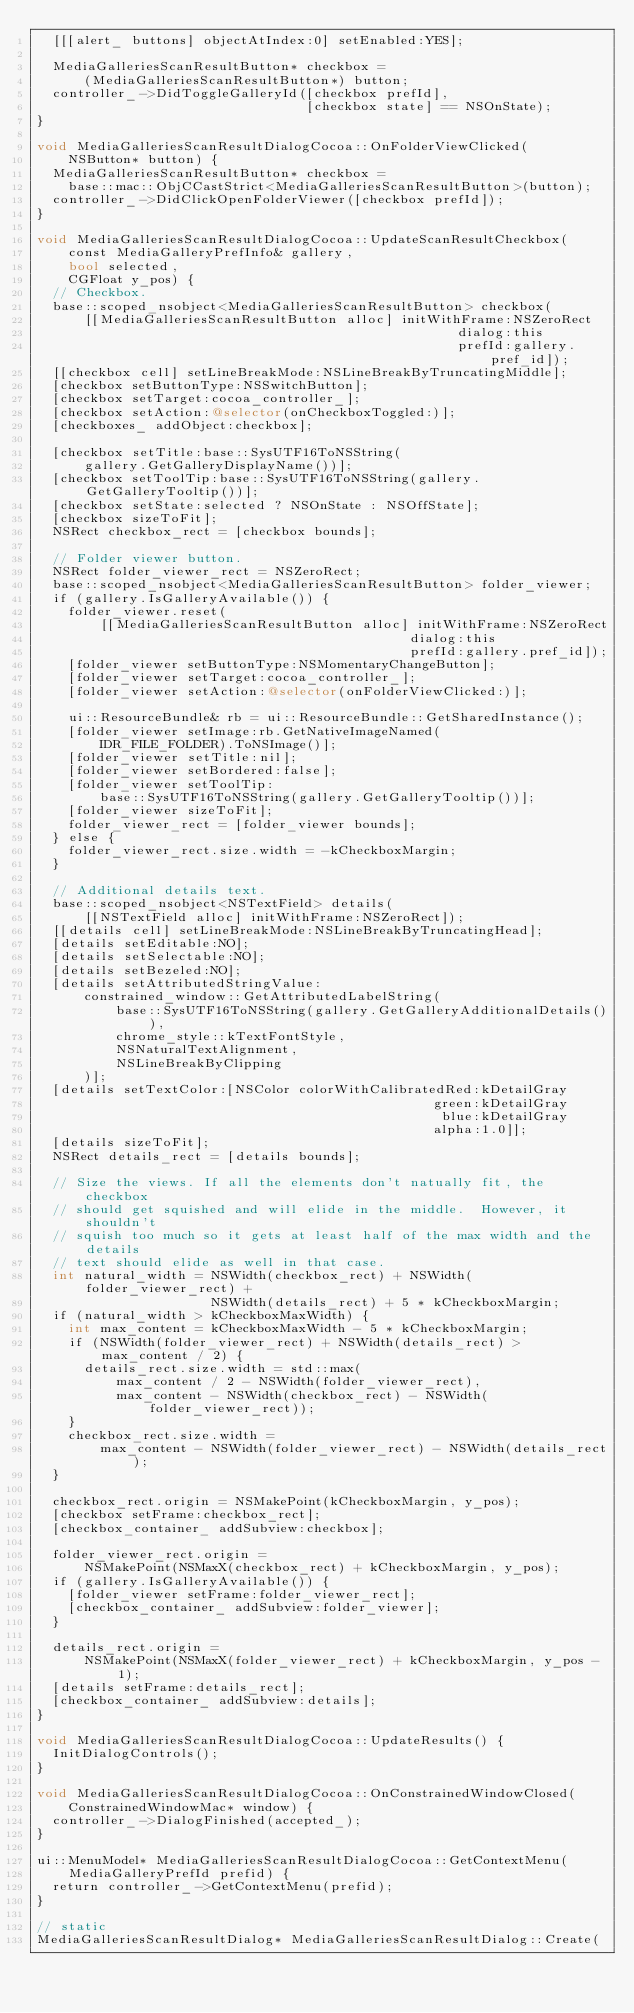<code> <loc_0><loc_0><loc_500><loc_500><_ObjectiveC_>  [[[alert_ buttons] objectAtIndex:0] setEnabled:YES];

  MediaGalleriesScanResultButton* checkbox =
      (MediaGalleriesScanResultButton*) button;
  controller_->DidToggleGalleryId([checkbox prefId],
                                  [checkbox state] == NSOnState);
}

void MediaGalleriesScanResultDialogCocoa::OnFolderViewClicked(
    NSButton* button) {
  MediaGalleriesScanResultButton* checkbox =
    base::mac::ObjCCastStrict<MediaGalleriesScanResultButton>(button);
  controller_->DidClickOpenFolderViewer([checkbox prefId]);
}

void MediaGalleriesScanResultDialogCocoa::UpdateScanResultCheckbox(
    const MediaGalleryPrefInfo& gallery,
    bool selected,
    CGFloat y_pos) {
  // Checkbox.
  base::scoped_nsobject<MediaGalleriesScanResultButton> checkbox(
      [[MediaGalleriesScanResultButton alloc] initWithFrame:NSZeroRect
                                                     dialog:this
                                                     prefId:gallery.pref_id]);
  [[checkbox cell] setLineBreakMode:NSLineBreakByTruncatingMiddle];
  [checkbox setButtonType:NSSwitchButton];
  [checkbox setTarget:cocoa_controller_];
  [checkbox setAction:@selector(onCheckboxToggled:)];
  [checkboxes_ addObject:checkbox];

  [checkbox setTitle:base::SysUTF16ToNSString(
      gallery.GetGalleryDisplayName())];
  [checkbox setToolTip:base::SysUTF16ToNSString(gallery.GetGalleryTooltip())];
  [checkbox setState:selected ? NSOnState : NSOffState];
  [checkbox sizeToFit];
  NSRect checkbox_rect = [checkbox bounds];

  // Folder viewer button.
  NSRect folder_viewer_rect = NSZeroRect;
  base::scoped_nsobject<MediaGalleriesScanResultButton> folder_viewer;
  if (gallery.IsGalleryAvailable()) {
    folder_viewer.reset(
        [[MediaGalleriesScanResultButton alloc] initWithFrame:NSZeroRect
                                               dialog:this
                                               prefId:gallery.pref_id]);
    [folder_viewer setButtonType:NSMomentaryChangeButton];
    [folder_viewer setTarget:cocoa_controller_];
    [folder_viewer setAction:@selector(onFolderViewClicked:)];

    ui::ResourceBundle& rb = ui::ResourceBundle::GetSharedInstance();
    [folder_viewer setImage:rb.GetNativeImageNamed(
        IDR_FILE_FOLDER).ToNSImage()];
    [folder_viewer setTitle:nil];
    [folder_viewer setBordered:false];
    [folder_viewer setToolTip:
        base::SysUTF16ToNSString(gallery.GetGalleryTooltip())];
    [folder_viewer sizeToFit];
    folder_viewer_rect = [folder_viewer bounds];
  } else {
    folder_viewer_rect.size.width = -kCheckboxMargin;
  }

  // Additional details text.
  base::scoped_nsobject<NSTextField> details(
      [[NSTextField alloc] initWithFrame:NSZeroRect]);
  [[details cell] setLineBreakMode:NSLineBreakByTruncatingHead];
  [details setEditable:NO];
  [details setSelectable:NO];
  [details setBezeled:NO];
  [details setAttributedStringValue:
      constrained_window::GetAttributedLabelString(
          base::SysUTF16ToNSString(gallery.GetGalleryAdditionalDetails()),
          chrome_style::kTextFontStyle,
          NSNaturalTextAlignment,
          NSLineBreakByClipping
      )];
  [details setTextColor:[NSColor colorWithCalibratedRed:kDetailGray
                                                  green:kDetailGray
                                                   blue:kDetailGray
                                                  alpha:1.0]];
  [details sizeToFit];
  NSRect details_rect = [details bounds];

  // Size the views. If all the elements don't natually fit, the checkbox
  // should get squished and will elide in the middle.  However, it shouldn't
  // squish too much so it gets at least half of the max width and the details
  // text should elide as well in that case.
  int natural_width = NSWidth(checkbox_rect) + NSWidth(folder_viewer_rect) +
                      NSWidth(details_rect) + 5 * kCheckboxMargin;
  if (natural_width > kCheckboxMaxWidth) {
    int max_content = kCheckboxMaxWidth - 5 * kCheckboxMargin;
    if (NSWidth(folder_viewer_rect) + NSWidth(details_rect) > max_content / 2) {
      details_rect.size.width = std::max(
          max_content / 2 - NSWidth(folder_viewer_rect),
          max_content - NSWidth(checkbox_rect) - NSWidth(folder_viewer_rect));
    }
    checkbox_rect.size.width =
        max_content - NSWidth(folder_viewer_rect) - NSWidth(details_rect);
  }

  checkbox_rect.origin = NSMakePoint(kCheckboxMargin, y_pos);
  [checkbox setFrame:checkbox_rect];
  [checkbox_container_ addSubview:checkbox];

  folder_viewer_rect.origin =
      NSMakePoint(NSMaxX(checkbox_rect) + kCheckboxMargin, y_pos);
  if (gallery.IsGalleryAvailable()) {
    [folder_viewer setFrame:folder_viewer_rect];
    [checkbox_container_ addSubview:folder_viewer];
  }

  details_rect.origin =
      NSMakePoint(NSMaxX(folder_viewer_rect) + kCheckboxMargin, y_pos - 1);
  [details setFrame:details_rect];
  [checkbox_container_ addSubview:details];
}

void MediaGalleriesScanResultDialogCocoa::UpdateResults() {
  InitDialogControls();
}

void MediaGalleriesScanResultDialogCocoa::OnConstrainedWindowClosed(
    ConstrainedWindowMac* window) {
  controller_->DialogFinished(accepted_);
}

ui::MenuModel* MediaGalleriesScanResultDialogCocoa::GetContextMenu(
    MediaGalleryPrefId prefid) {
  return controller_->GetContextMenu(prefid);
}

// static
MediaGalleriesScanResultDialog* MediaGalleriesScanResultDialog::Create(</code> 